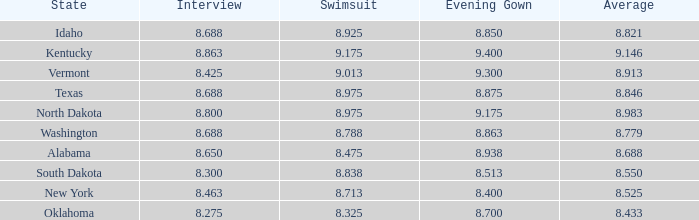What is the lowest evening score of the contestant with an evening gown less than 8.938, from Texas, and with an average less than 8.846 has? None. Would you mind parsing the complete table? {'header': ['State', 'Interview', 'Swimsuit', 'Evening Gown', 'Average'], 'rows': [['Idaho', '8.688', '8.925', '8.850', '8.821'], ['Kentucky', '8.863', '9.175', '9.400', '9.146'], ['Vermont', '8.425', '9.013', '9.300', '8.913'], ['Texas', '8.688', '8.975', '8.875', '8.846'], ['North Dakota', '8.800', '8.975', '9.175', '8.983'], ['Washington', '8.688', '8.788', '8.863', '8.779'], ['Alabama', '8.650', '8.475', '8.938', '8.688'], ['South Dakota', '8.300', '8.838', '8.513', '8.550'], ['New York', '8.463', '8.713', '8.400', '8.525'], ['Oklahoma', '8.275', '8.325', '8.700', '8.433']]} 